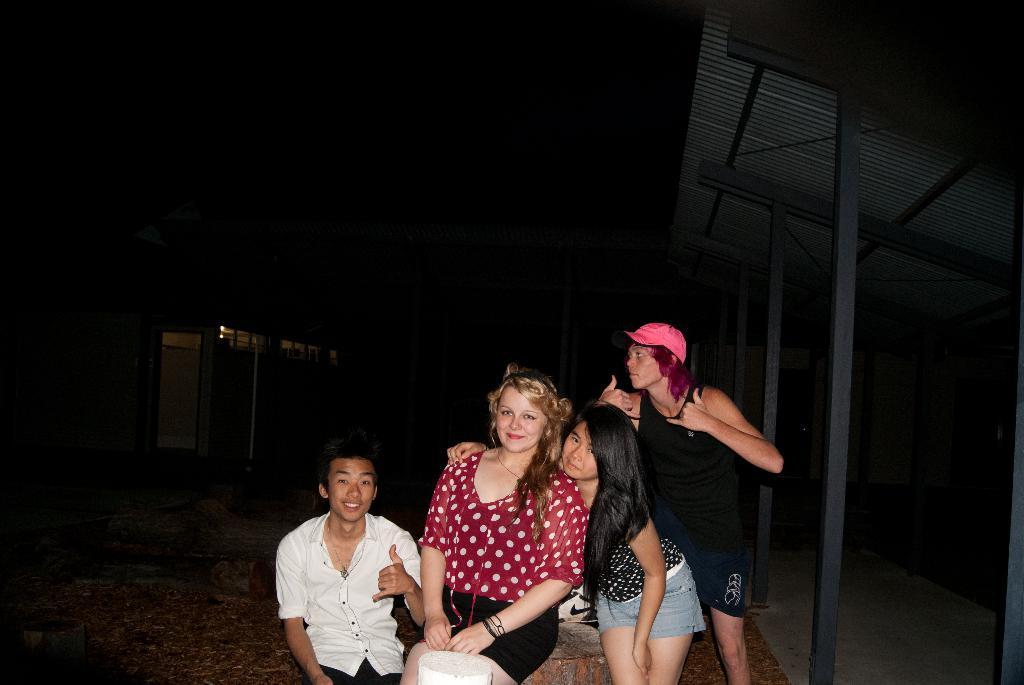What types of people are present in the image? There are women and men in the image. Can you describe the setting of the image? There is a house in the background of the image. What is the position of the man in the image? There is a man standing in the image. What is the man wearing on his head? The man is wearing a cap. What object can be seen in the image that might be used for carrying items? There is a paper bag in the image. What type of food is being prepared in the image? There is no food or preparation of food visible in the image. How many clocks can be seen in the image? There are no clocks present in the image. 